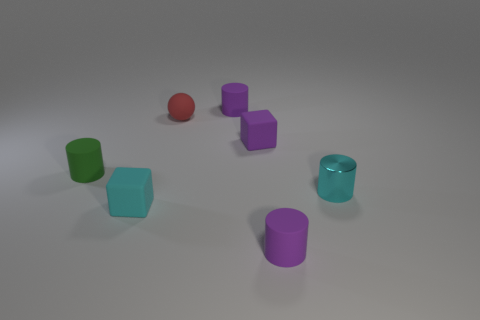Can you compare the sizes of the objects in the image? Certainly! In the image, you can notice that the objects come in various sizes. The red sphere and the cubes appear to be of similar proportions, while the cylinders vary slightly with two being slightly larger. The purple cylinders could be described as medium-sized relative to others, and when carefully observed, the green cylinder seems to stand out as the smallest object among them. 